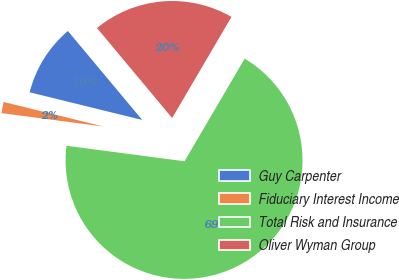<chart> <loc_0><loc_0><loc_500><loc_500><pie_chart><fcel>Guy Carpenter<fcel>Fiduciary Interest Income<fcel>Total Risk and Insurance<fcel>Oliver Wyman Group<nl><fcel>10.09%<fcel>1.75%<fcel>68.65%<fcel>19.52%<nl></chart> 